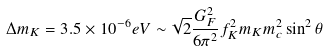<formula> <loc_0><loc_0><loc_500><loc_500>\Delta m _ { K } = 3 . 5 \times 1 0 ^ { - 6 } e V \sim \sqrt { 2 } \frac { G _ { F } ^ { 2 } } { 6 \pi ^ { 2 } } f _ { K } ^ { 2 } m _ { K } m _ { c } ^ { 2 } \sin ^ { 2 } \theta</formula> 